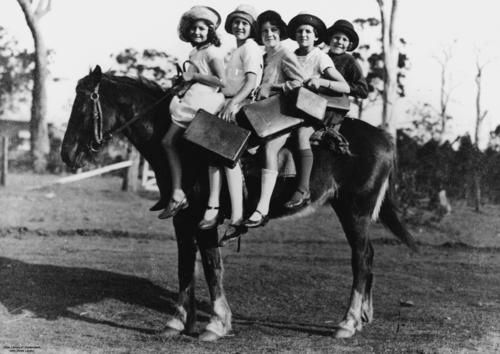Describe the objects in this image and their specific colors. I can see horse in white, black, gray, darkgray, and lightgray tones, people in white, black, darkgray, lightgray, and gray tones, people in white, darkgray, lightgray, black, and gray tones, people in white, darkgray, black, lightgray, and gray tones, and people in white, black, gray, darkgray, and lightgray tones in this image. 